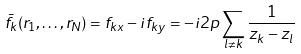<formula> <loc_0><loc_0><loc_500><loc_500>\bar { f } _ { k } ( { r } _ { 1 } , \dots , { r } _ { N } ) = f _ { k x } - i f _ { k y } = - i 2 p \sum _ { l \neq k } \frac { 1 } { z _ { k } - z _ { l } }</formula> 